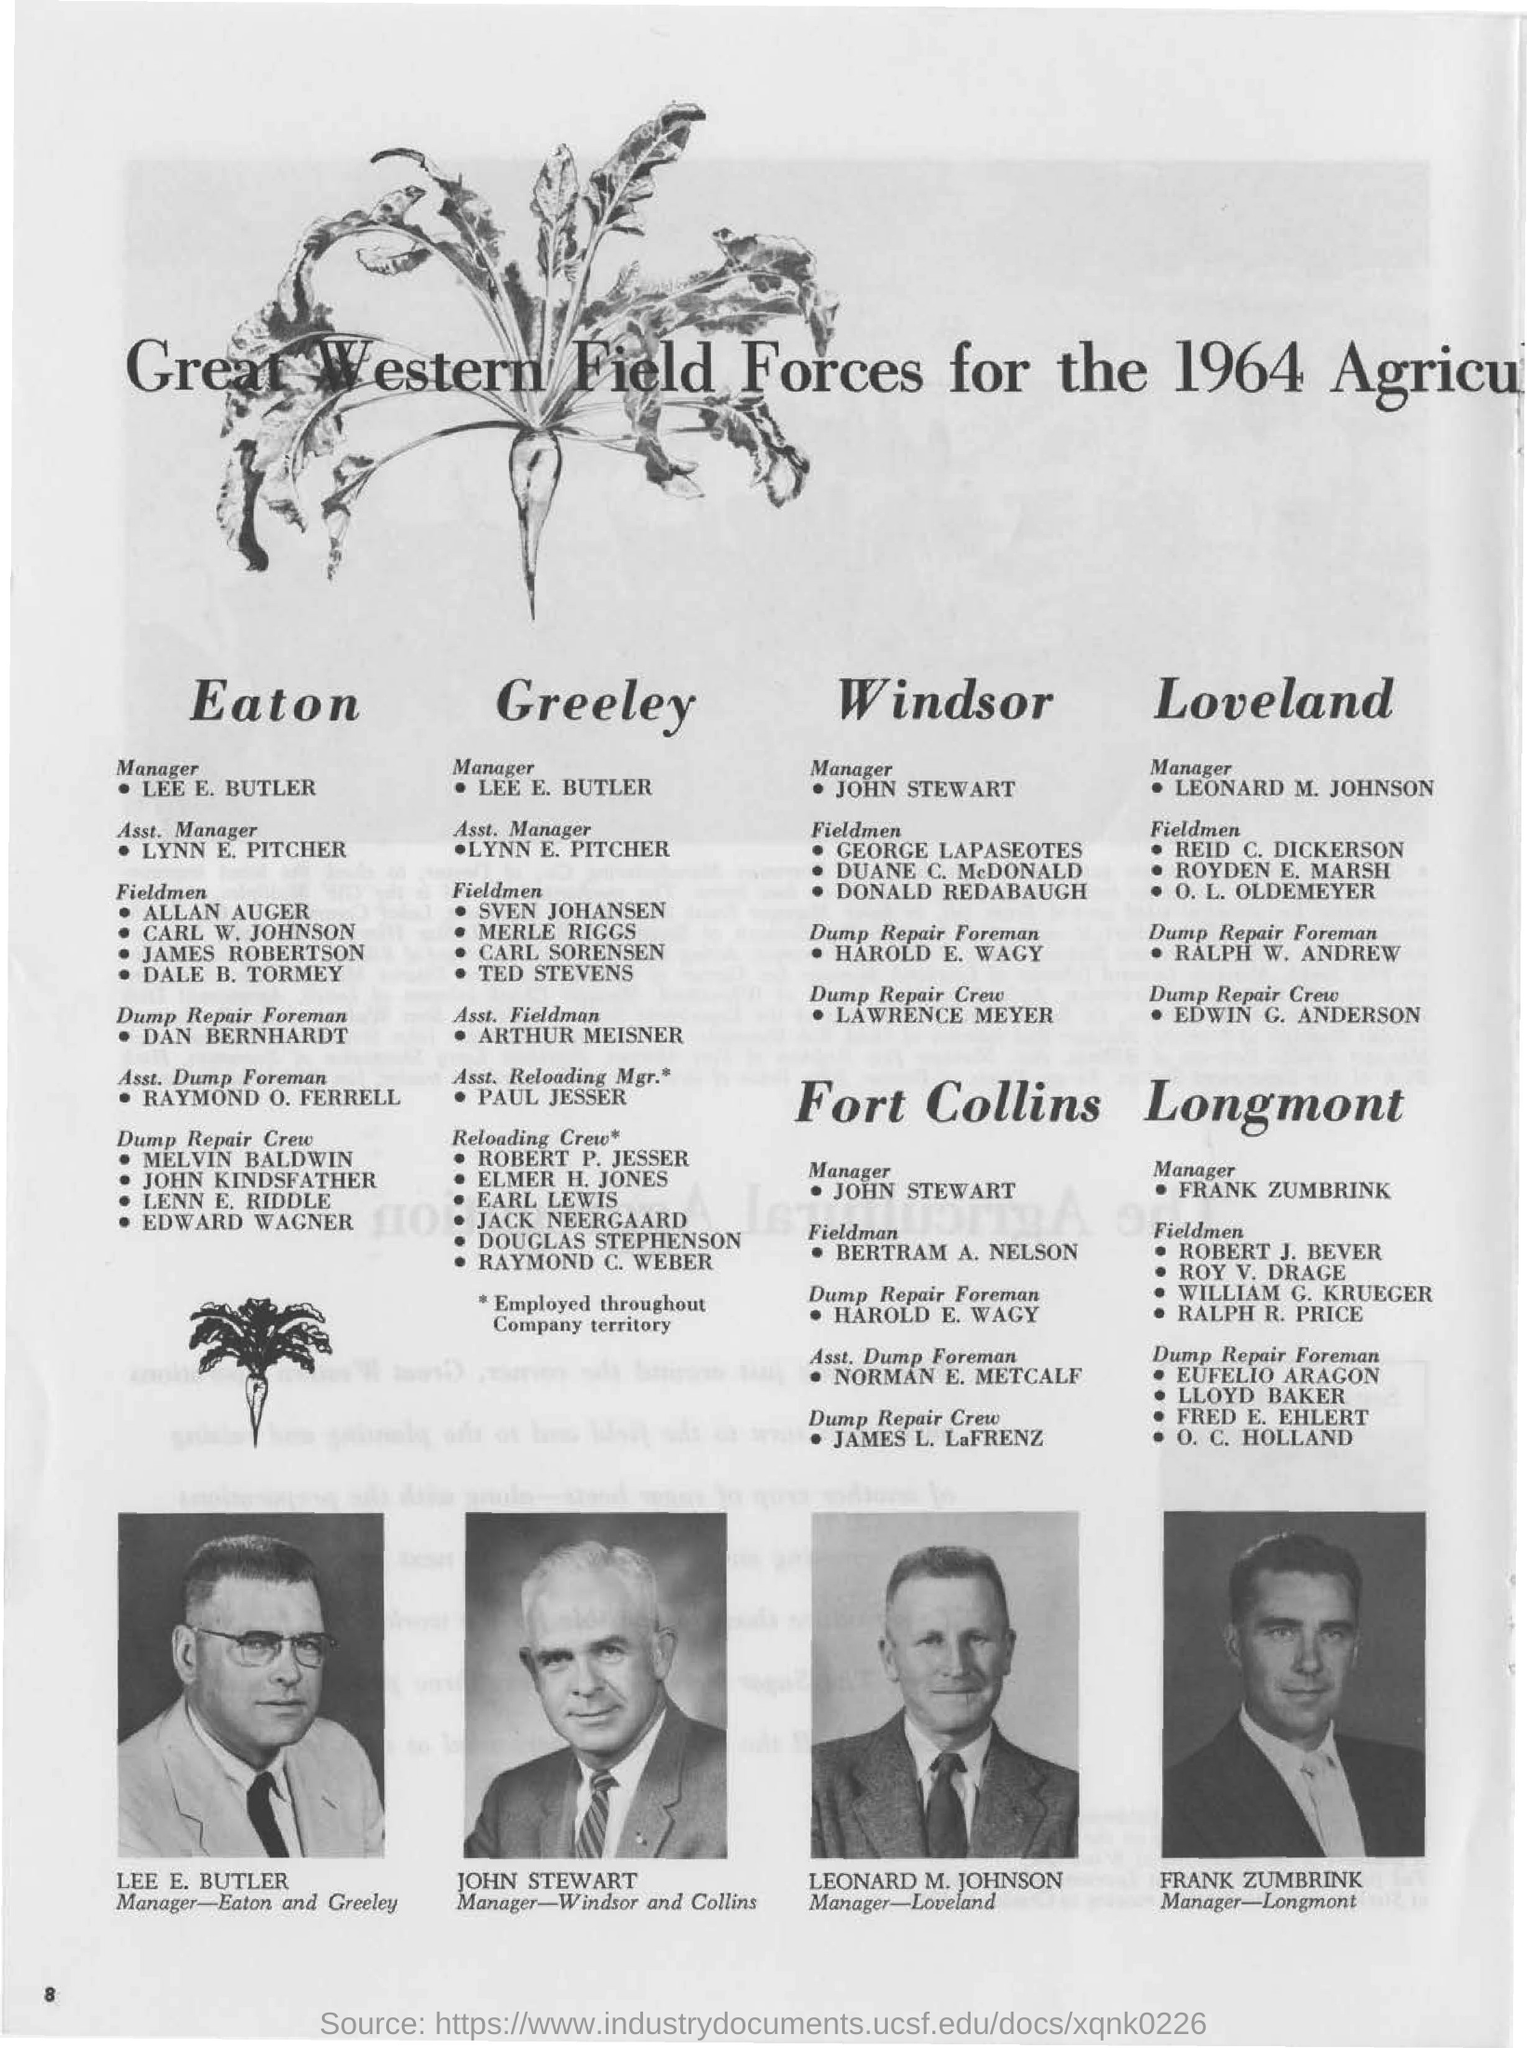What is the designation of John Stewart?
Ensure brevity in your answer.  Manager. Who is the Manager-Loveland?
Offer a terse response. LEONARD M. JOHNSON. What is the page no mentioned in this document?
Provide a succinct answer. 8. Who is the Manager-Longmont?
Make the answer very short. FRANK ZUMBRINK. 